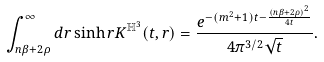Convert formula to latex. <formula><loc_0><loc_0><loc_500><loc_500>\int _ { n \beta + 2 \rho } ^ { \infty } d r \sinh r K ^ { \mathbb { H } ^ { 3 } } ( t , r ) = \frac { e ^ { - ( m ^ { 2 } + 1 ) t - \frac { ( n \beta + 2 \rho ) ^ { 2 } } { 4 t } } } { 4 \pi ^ { 3 / 2 } \sqrt { t } } .</formula> 